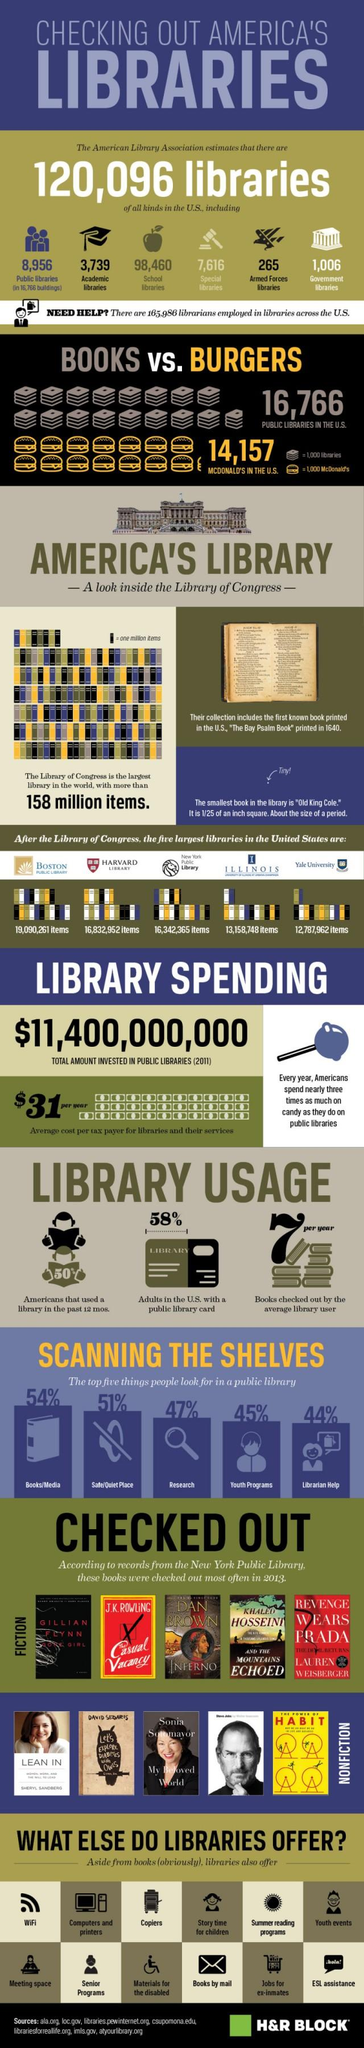Mention a couple of crucial points in this snapshot. As of 2021, there are a total of 102,199 academic and school libraries in the country. Public libraries are more numerous than McDonald's restaurants in the United States. The third largest library in the United States is Harvard library. The book that was checked out most frequently in nonfiction in 2013 is the one that is listed first in the list of nonfiction books that were checked out most often in 2013. There are a total of 9,962 public and government libraries in the country. 